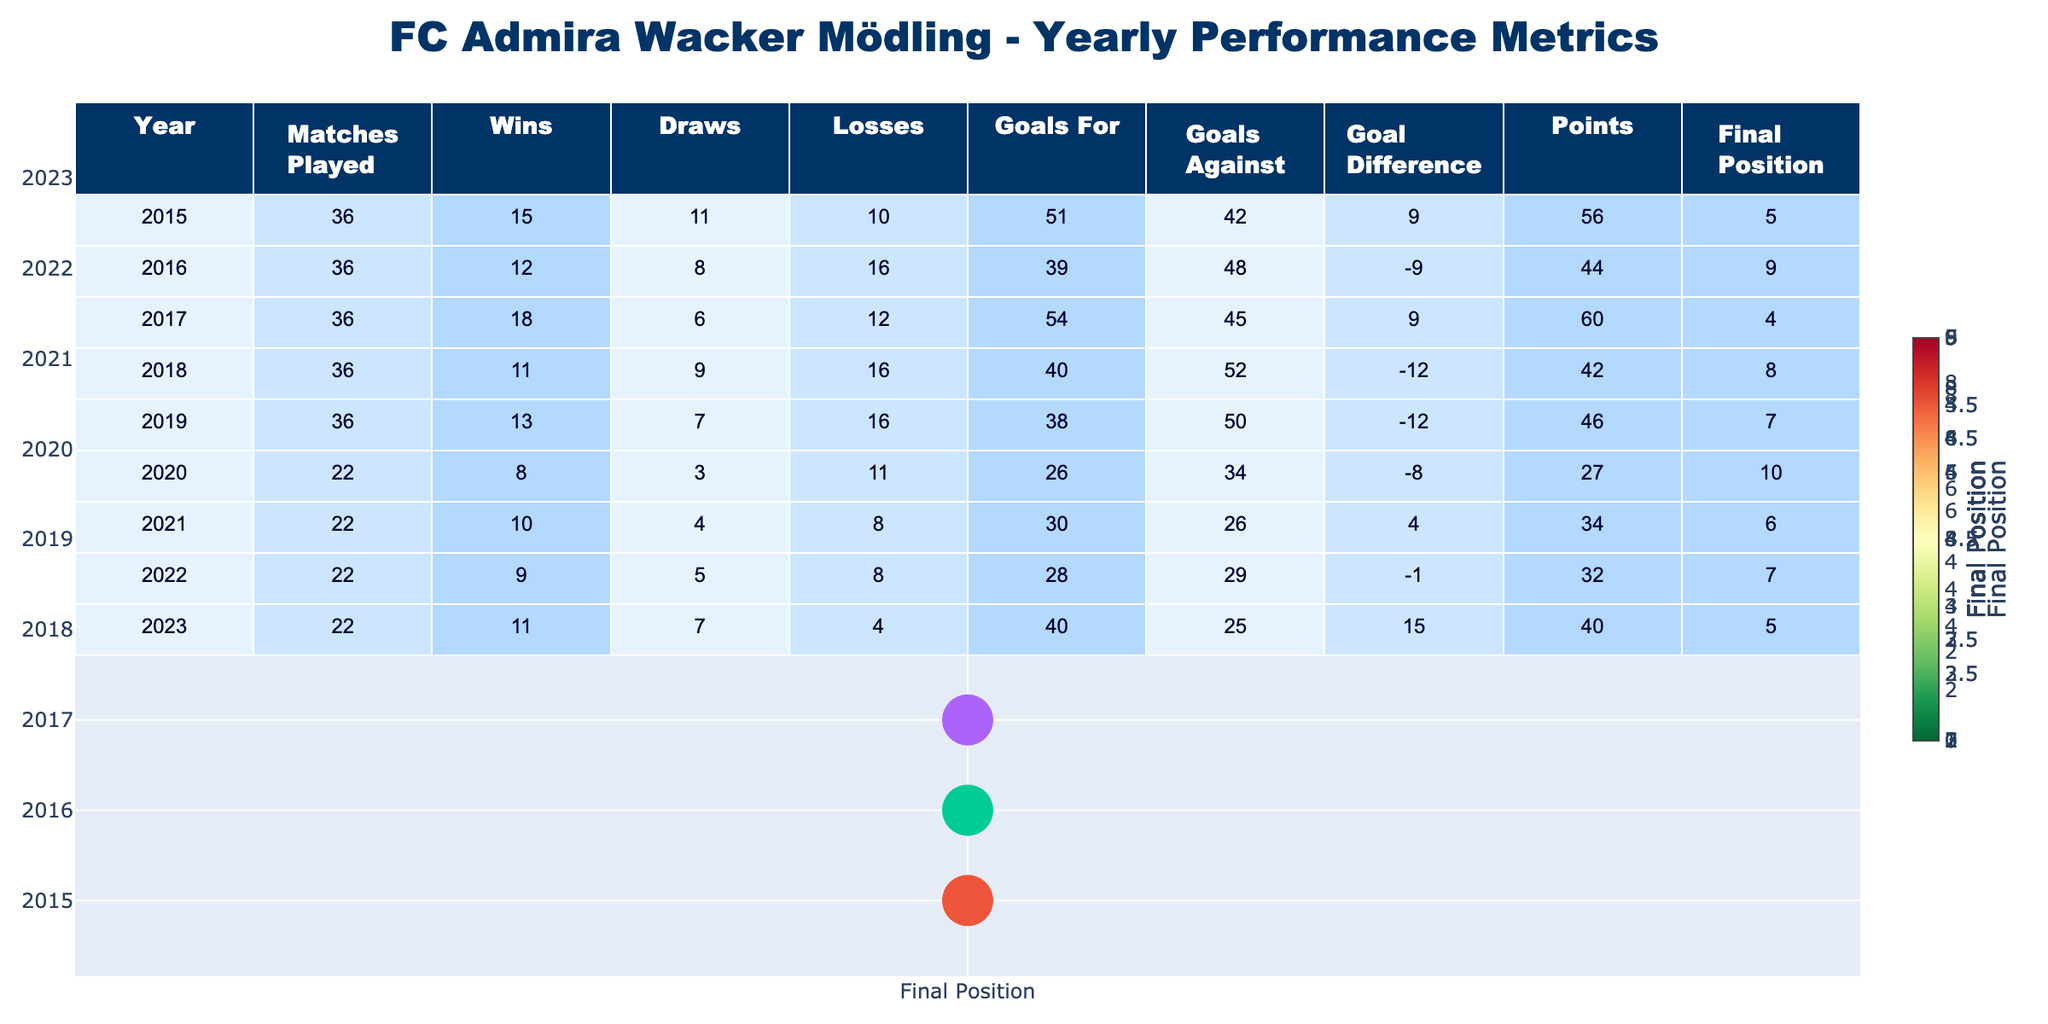What was FC Admira Wacker Mödling's highest points total in a single season? The highest points total can be found by scanning the 'Points' column. The greatest value is 60, which occurred in the year 2017.
Answer: 60 Which year did FC Admira Wacker Mödling have the most wins? By looking at the 'Wins' column, the maximum number of wins is 18, which was in 2017.
Answer: 2017 In which year did the team achieve a goal difference of 15? Checking the 'Goal Difference' column, the only year with a value of 15 is 2023.
Answer: 2023 What was the average points per match for the team in the 2019 season? In the 2019 season, FC Admira played 36 matches and earned 46 points. The average points per match is calculated as 46/36, which equals approximately 1.28.
Answer: 1.28 Did the team finish higher in 2021 or 2022? Comparing the 'Final Position' for 2021 (6) and 2022 (7), a lower number indicates a better rank. Thus, the team finished higher in 2021.
Answer: 2021 What is the total number of losses across all seasons? The total losses can be found by summing the 'Losses' column: 10 + 16 + 12 + 16 + 16 + 11 + 8 + 4 = 93.
Answer: 93 In how many seasons did the team score more goals than they conceded? By evaluating the 'Goals For' and 'Goals Against', goals were scored more than conceded in the years 2015, 2017, and 2023, totaling 3 seasons.
Answer: 3 What was the difference in points between the seasons with the highest (2017) and lowest (2020) points? The highest points in 2017 were 60, and the lowest in 2020 were 27. The difference in points is 60 - 27 = 33.
Answer: 33 Was there a year where the team had a negative goal difference but still finished in the top half of the standings? Looking at the 'Goal Difference' and 'Final Position', the team had a negative goal difference in 2018 (-12) and finished 8th, which is not in the top half. So, the answer is no.
Answer: No Which season had the best goal-scoring record based on goals scored? The best goal-scoring record can be found in the 'Goals For' column, where the highest value is 54 in 2017.
Answer: 2017 